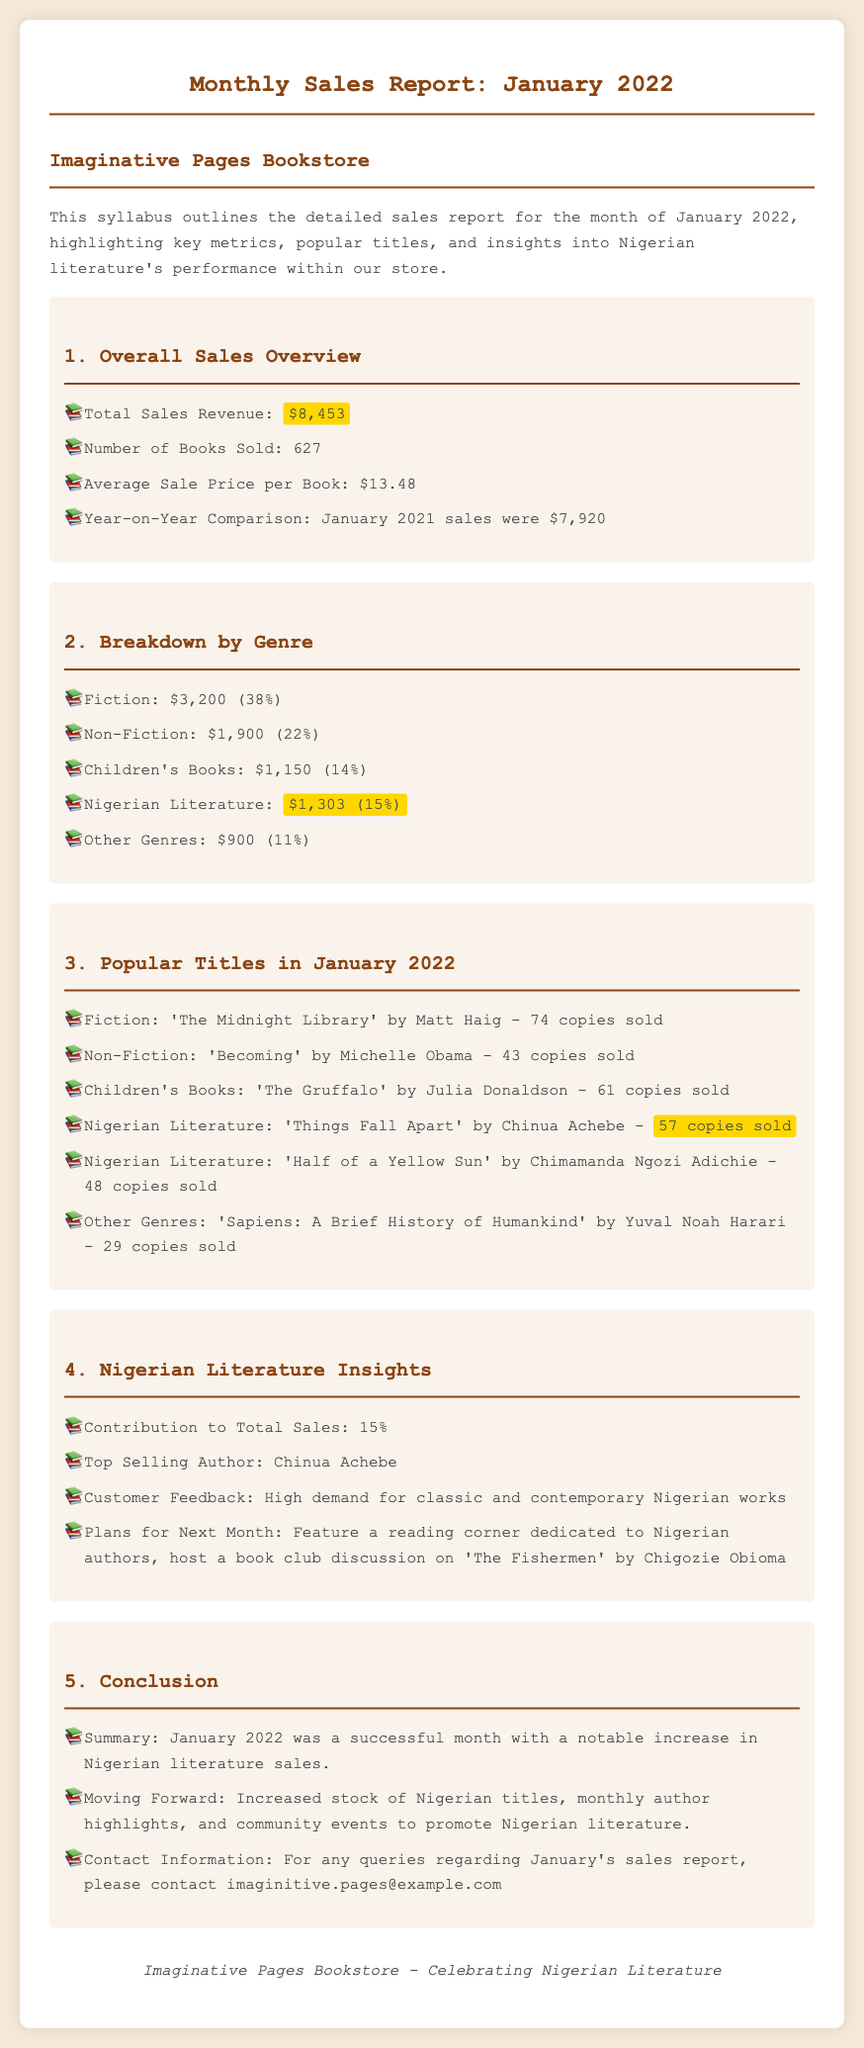What was the total sales revenue for January 2022? The total sales revenue is explicitly stated in the document as $8,453.
Answer: $8,453 How many books were sold in January 2022? The document specifies the total number of books sold as 627.
Answer: 627 What percentage of total sales did Nigerian literature contribute? The sales contribution of Nigerian literature is highlighted as 15% in the document.
Answer: 15% Which was the top-selling title in Nigerian literature? The document lists 'Things Fall Apart' by Chinua Achebe as the top-selling title with 57 copies sold.
Answer: 'Things Fall Apart' Who is the top-selling author in Nigerian literature? The report identifies Chinua Achebe as the top-selling author in Nigerian literature.
Answer: Chinua Achebe What genre had the highest sales revenue? The document indicates that Fiction had the highest sales revenue of $3,200.
Answer: Fiction What was the year-on-year sales comparison figure for January 2021? The document states that January 2021 sales were $7,920, which is a comparative figure to assess growth.
Answer: $7,920 What future plans does the bookstore have for Nigerian literature? The document outlines plans to feature a reading corner dedicated to Nigerian authors and host a book club discussion.
Answer: Feature a reading corner What was the average sale price per book? The average sale price per book is calculated and indicated as $13.48 in the document.
Answer: $13.48 